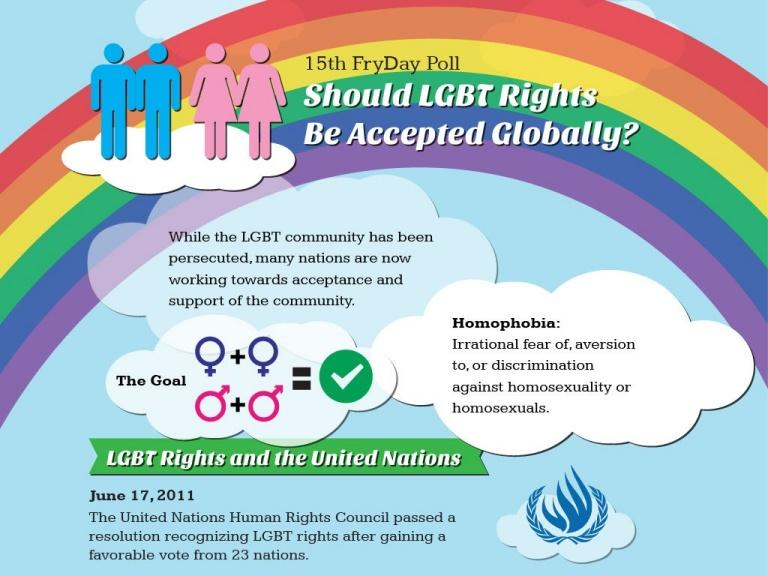Point out several critical features in this image. The males are represented in blue in this scenario. 